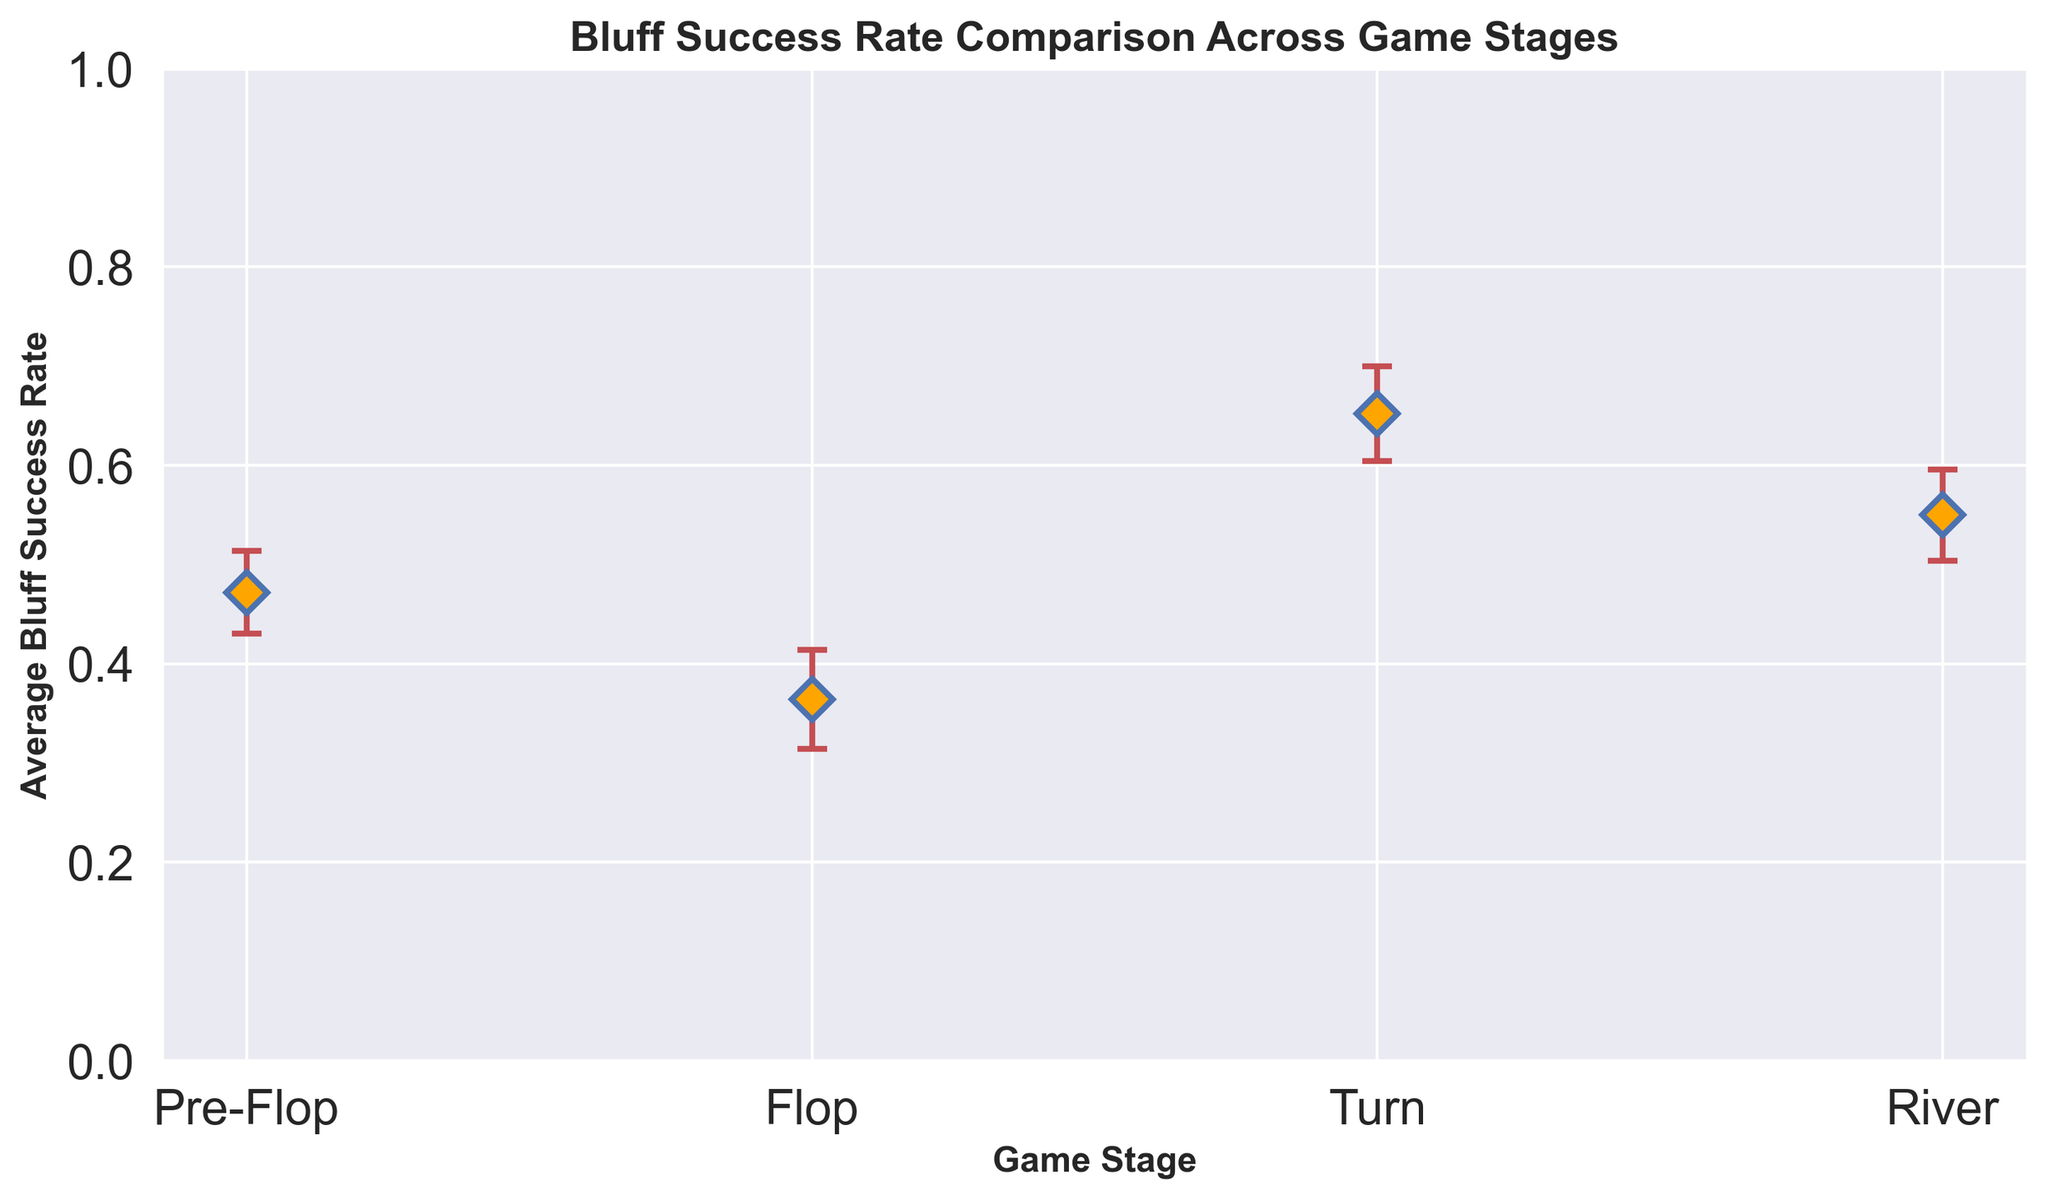What is the average Bluff Success Rate during the Flop stage? The data shows five Bluff Success Rates during the Flop stage: 0.45, 0.48, 0.46, 0.50, and 0.47. Summing these values gives 2.36, and dividing by 5 gives us the average Bluff Success Rate as 0.472
Answer: 0.472 In which game stage is the average Bluff Success Rate the highest? Examining the average Bluff Success Rates provided in the errorbar chart, the River stage has the highest average Bluff Success Rate of approximately 0.65
Answer: River Which game stage shows the least variation in Bluff Success Rate, as indicated by the error bars? The error bars indicate the amount of error in the measurements. The Flop stage has the smallest average error (around 0.04) among the stages, suggesting the least variation in Bluff Success Rate
Answer: Flop How does the average Bluff Success Rate of the Turn stage compare to that of the River stage? According to the chart, the Turn stage has an average Bluff Success Rate of around 0.55, while the River stage has an average Bluff Success Rate of around 0.65. This shows that the Turn stage has a lower average Bluff Success Rate compared to the River stage
Answer: Lower What is the total average error across all game stages? The average errors are: Pre-Flop (0.05), Flop (0.04), Turn (0.046), and River (0.048). Summing these errors gives 0.05 + 0.04 + 0.046 + 0.048 = 0.184
Answer: 0.184 In terms of average Bluff Success Rate, by how much does the Flop stage exceed the Pre-Flop stage? The Flop stage has an average Bluff Success Rate of 0.472, while the Pre-Flop stage has an average Bluff Success Rate of around 0.36. Hence, the Flop stage exceeds the Pre-Flop stage by 0.472 - 0.36 = 0.112
Answer: 0.112 If we focus on the confidence in our results, which stage should we be least confident about? The stage with the highest average error indicates the least confidence. The Pre-Flop and Turn stages have the highest average error of approximately 0.05 each, suggesting similar levels of lower confidence
Answer: Pre-Flop and Turn Considering the error bars, which game's stage Bluff Success Rate measurement overlaps most with another stage? The error bars of the Turn and River stages overlap the most, as their ranges are closest to each other visually
Answer: Turn and River By how much does the average Bluff Success Rate increase from the Pre-Flop stage to the River stage? The average Bluff Success Rate in the Pre-Flop stage is approximately 0.36, and in the River stage, it is around 0.65. Therefore, the increase is 0.65 - 0.36 = 0.29
Answer: 0.29 